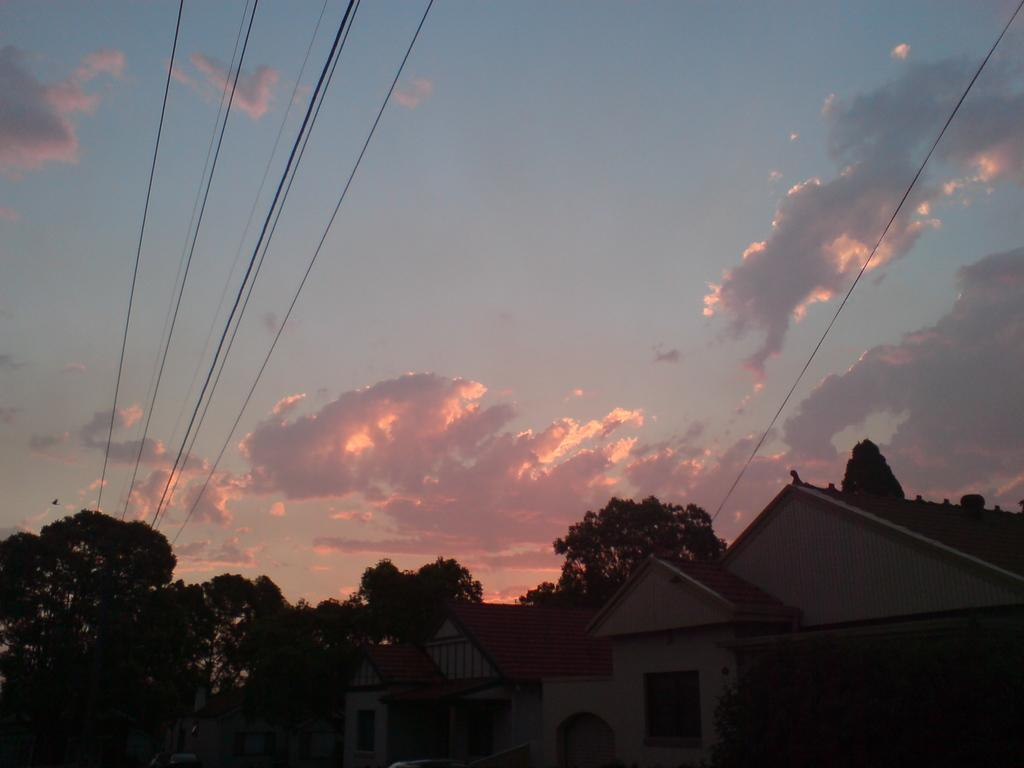What type of structures can be seen in the image? There are houses in the image. What other natural elements are present in the image? There are trees in the image. Are there any man-made objects visible in the image? Yes, there are wires visible in the image. What is visible in the background of the image? The sky is visible in the image, and clouds are present in the sky. Can you see a mountain in the image? There is no mountain present in the image. What type of bone is visible in the image? There are no bones present in the image. 